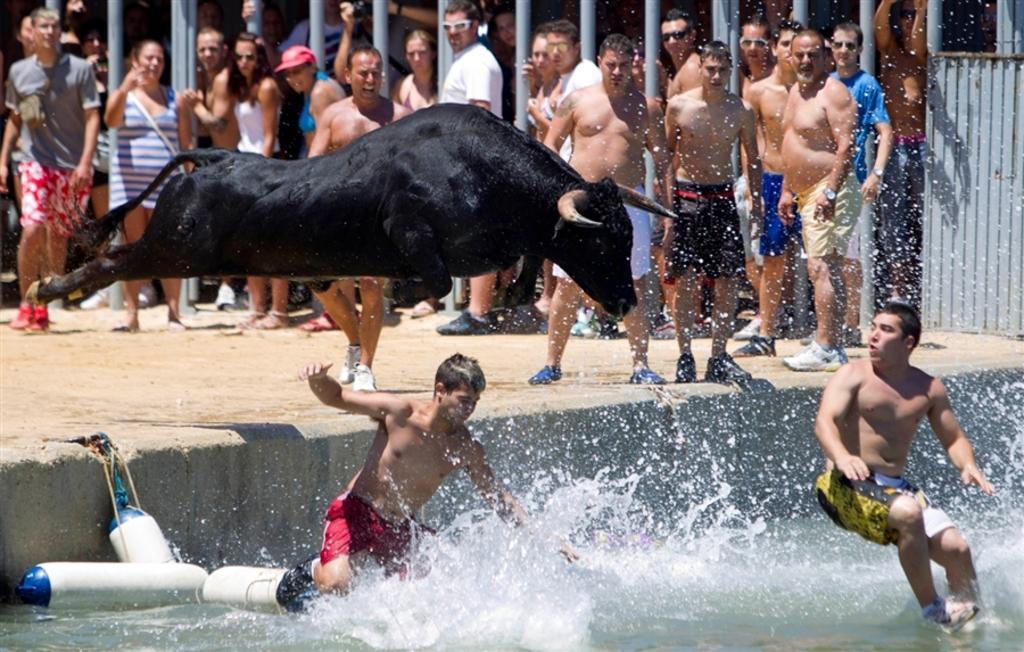Describe this image in one or two sentences. In this picture we can see group of people and a bull, and we can find few people in the water, in the background we can see few metal rods. 